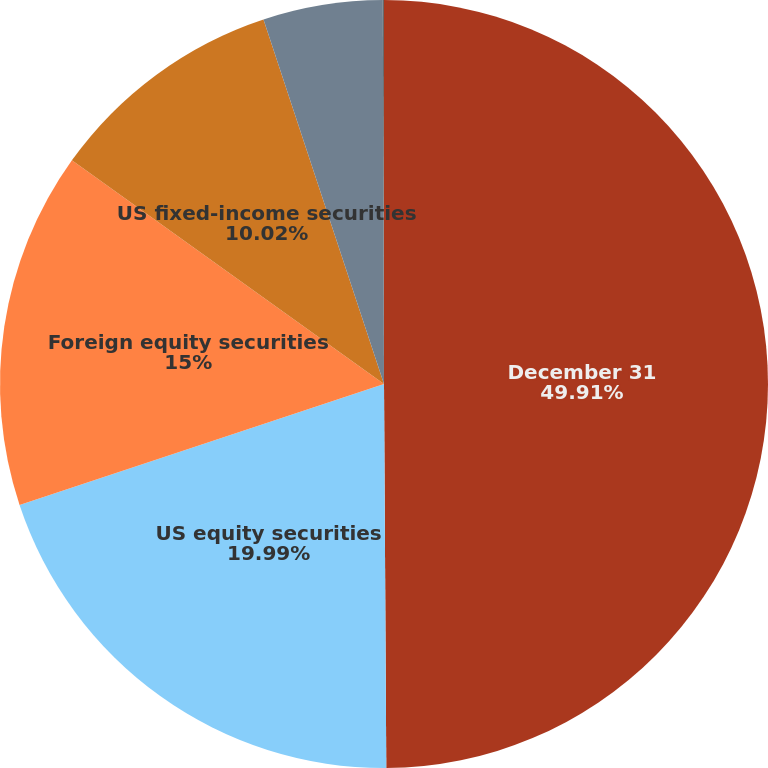Convert chart. <chart><loc_0><loc_0><loc_500><loc_500><pie_chart><fcel>December 31<fcel>US equity securities<fcel>Foreign equity securities<fcel>US fixed-income securities<fcel>Foreign fixed-income<fcel>Alternative investments<nl><fcel>49.9%<fcel>19.99%<fcel>15.0%<fcel>10.02%<fcel>5.03%<fcel>0.05%<nl></chart> 